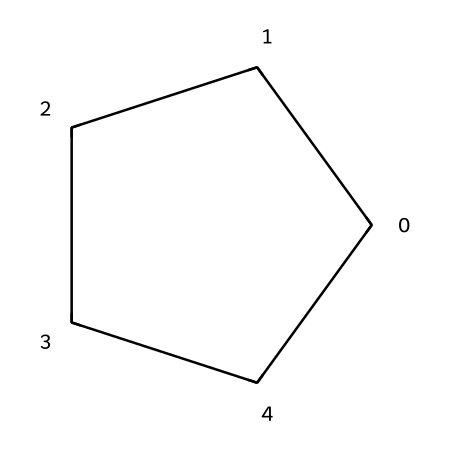What is the name of this compound? The SMILES representation C1CCCC1 indicates a six-membered carbon ring, which classifies it as cyclopentane.
Answer: cyclopentane How many carbon atoms are in cyclopentane? The SMILES shows five carbon atoms (C) in the ring structure.
Answer: 5 What type of bonds are present in cyclopentane? The structure depicted has single bonds (sigma bonds) between the carbon atoms, as it is a saturated compound.
Answer: single bonds What is the molecular formula of cyclopentane? Adding the number of carbon and hydrogen atoms indicates there are 5 carbon atoms and 10 hydrogen atoms (C5H10).
Answer: C5H10 Why is cyclopentane considered a cycloalkane? Cyclopentane has a closed ring structure comprising only carbon and hydrogen, which is characteristic of cycloalkanes.
Answer: cycloalkane What is the hybridization of the carbon atoms in cyclopentane? Each carbon atom in cyclopentane is bonded to two other carbon atoms and two hydrogen atoms, resulting in sp3 hybridization.
Answer: sp3 How does cyclopentane compare in stability to open-chain alkanes? Cyclopentane has a stable structure due to its cyclic form, though it is less stable than larger cycloalkanes due to angle strain.
Answer: less stable 